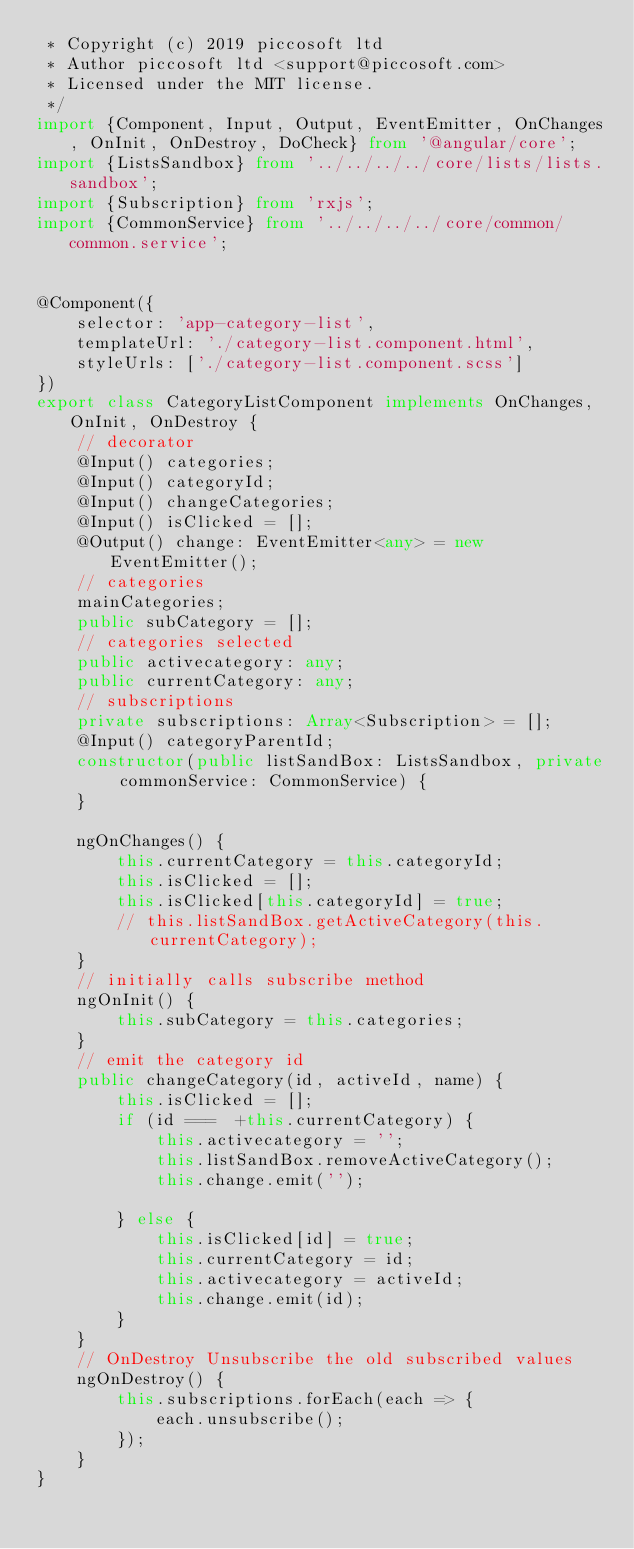Convert code to text. <code><loc_0><loc_0><loc_500><loc_500><_TypeScript_> * Copyright (c) 2019 piccosoft ltd
 * Author piccosoft ltd <support@piccosoft.com>
 * Licensed under the MIT license.
 */
import {Component, Input, Output, EventEmitter, OnChanges, OnInit, OnDestroy, DoCheck} from '@angular/core';
import {ListsSandbox} from '../../../../core/lists/lists.sandbox';
import {Subscription} from 'rxjs';
import {CommonService} from '../../../../core/common/common.service';


@Component({
    selector: 'app-category-list',
    templateUrl: './category-list.component.html',
    styleUrls: ['./category-list.component.scss']
})
export class CategoryListComponent implements OnChanges, OnInit, OnDestroy {
    // decorator
    @Input() categories;
    @Input() categoryId;
    @Input() changeCategories;
    @Input() isClicked = [];
    @Output() change: EventEmitter<any> = new EventEmitter();
    // categories
    mainCategories;
    public subCategory = [];
    // categories selected
    public activecategory: any;
    public currentCategory: any;
    // subscriptions
    private subscriptions: Array<Subscription> = [];
    @Input() categoryParentId;
    constructor(public listSandBox: ListsSandbox, private commonService: CommonService) {
    }

    ngOnChanges() {
        this.currentCategory = this.categoryId;
        this.isClicked = [];
        this.isClicked[this.categoryId] = true;
        // this.listSandBox.getActiveCategory(this.currentCategory);
    }
    // initially calls subscribe method
    ngOnInit() {
        this.subCategory = this.categories;
    }
    // emit the category id
    public changeCategory(id, activeId, name) {
        this.isClicked = [];
        if (id ===  +this.currentCategory) {
            this.activecategory = '';
            this.listSandBox.removeActiveCategory();
            this.change.emit('');

        } else {
            this.isClicked[id] = true;
            this.currentCategory = id;
            this.activecategory = activeId;
            this.change.emit(id);
        }
    }
    // OnDestroy Unsubscribe the old subscribed values
    ngOnDestroy() {
        this.subscriptions.forEach(each => {
            each.unsubscribe();
        });
    }
}

</code> 